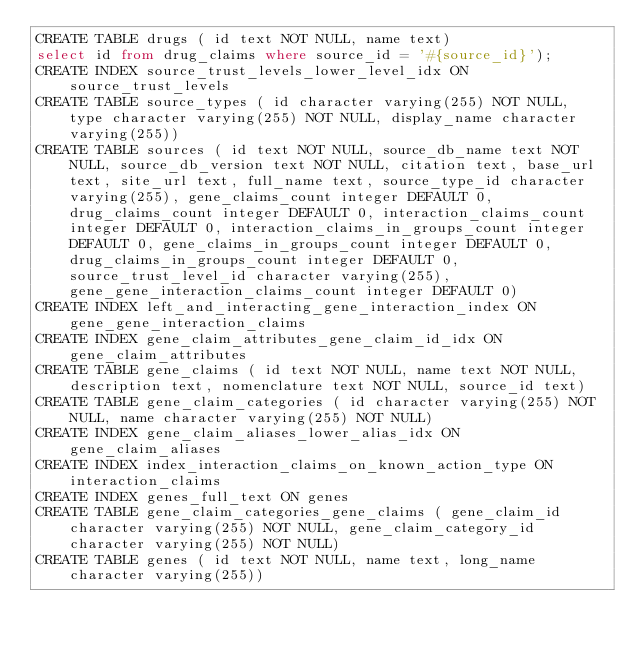Convert code to text. <code><loc_0><loc_0><loc_500><loc_500><_SQL_>CREATE TABLE drugs ( id text NOT NULL, name text)
select id from drug_claims where source_id = '#{source_id}');
CREATE INDEX source_trust_levels_lower_level_idx ON source_trust_levels 
CREATE TABLE source_types ( id character varying(255) NOT NULL, type character varying(255) NOT NULL, display_name character varying(255))
CREATE TABLE sources ( id text NOT NULL, source_db_name text NOT NULL, source_db_version text NOT NULL, citation text, base_url text, site_url text, full_name text, source_type_id character varying(255), gene_claims_count integer DEFAULT 0, drug_claims_count integer DEFAULT 0, interaction_claims_count integer DEFAULT 0, interaction_claims_in_groups_count integer DEFAULT 0, gene_claims_in_groups_count integer DEFAULT 0, drug_claims_in_groups_count integer DEFAULT 0, source_trust_level_id character varying(255), gene_gene_interaction_claims_count integer DEFAULT 0)
CREATE INDEX left_and_interacting_gene_interaction_index ON gene_gene_interaction_claims 
CREATE INDEX gene_claim_attributes_gene_claim_id_idx ON gene_claim_attributes 
CREATE TABLE gene_claims ( id text NOT NULL, name text NOT NULL, description text, nomenclature text NOT NULL, source_id text)
CREATE TABLE gene_claim_categories ( id character varying(255) NOT NULL, name character varying(255) NOT NULL)
CREATE INDEX gene_claim_aliases_lower_alias_idx ON gene_claim_aliases 
CREATE INDEX index_interaction_claims_on_known_action_type ON interaction_claims 
CREATE INDEX genes_full_text ON genes 
CREATE TABLE gene_claim_categories_gene_claims ( gene_claim_id character varying(255) NOT NULL, gene_claim_category_id character varying(255) NOT NULL)
CREATE TABLE genes ( id text NOT NULL, name text, long_name character varying(255))</code> 